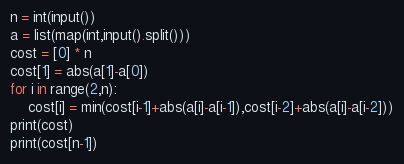<code> <loc_0><loc_0><loc_500><loc_500><_Python_>n = int(input())
a = list(map(int,input().split()))
cost = [0] * n
cost[1] = abs(a[1]-a[0])
for i in range(2,n):
    cost[i] = min(cost[i-1]+abs(a[i]-a[i-1]),cost[i-2]+abs(a[i]-a[i-2]))
print(cost)
print(cost[n-1])</code> 